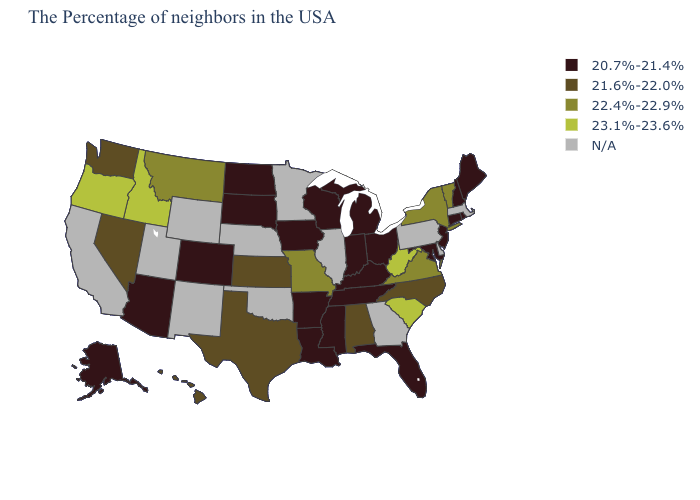Among the states that border South Dakota , which have the highest value?
Keep it brief. Montana. Does the first symbol in the legend represent the smallest category?
Give a very brief answer. Yes. Name the states that have a value in the range 22.4%-22.9%?
Write a very short answer. Vermont, New York, Virginia, Missouri, Montana. How many symbols are there in the legend?
Quick response, please. 5. Among the states that border Texas , which have the lowest value?
Answer briefly. Louisiana, Arkansas. What is the lowest value in states that border North Carolina?
Be succinct. 20.7%-21.4%. Name the states that have a value in the range 22.4%-22.9%?
Keep it brief. Vermont, New York, Virginia, Missouri, Montana. What is the lowest value in states that border Nebraska?
Write a very short answer. 20.7%-21.4%. What is the value of Minnesota?
Answer briefly. N/A. What is the value of Alaska?
Write a very short answer. 20.7%-21.4%. Does Rhode Island have the highest value in the Northeast?
Be succinct. No. How many symbols are there in the legend?
Answer briefly. 5. Does Idaho have the highest value in the USA?
Quick response, please. Yes. Does South Carolina have the lowest value in the USA?
Be succinct. No. Among the states that border Oklahoma , does Missouri have the lowest value?
Write a very short answer. No. 